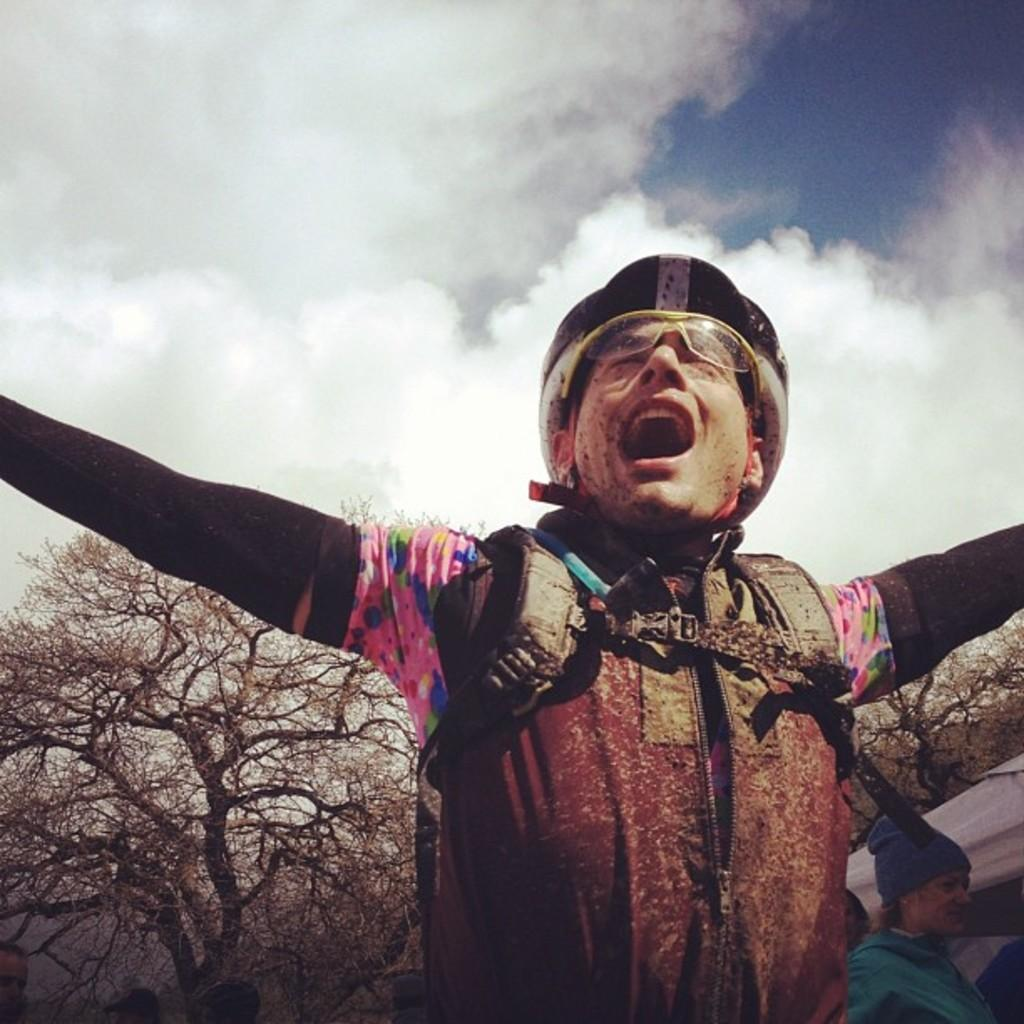What is the man in the image wearing on his head? The man in the image is wearing a helmet. Can you describe the other person in the image? There is another person in the image, but no specific details are provided about them. What type of natural vegetation can be seen in the image? There are trees in the image. What is visible in the background of the image? The sky is visible in the background of the image. What type of copper rock is being burned by the man in the image? There is no copper rock or any indication of burning in the image. 